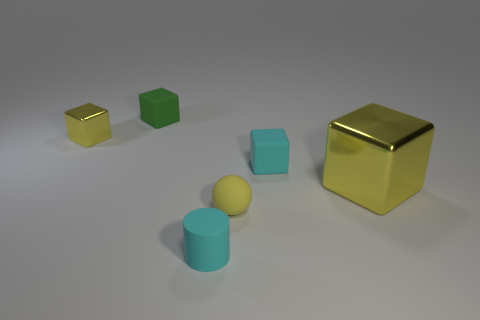How many things are to the left of the cyan matte object that is right of the cyan rubber cylinder?
Your response must be concise. 4. There is a cyan cylinder; are there any rubber cubes in front of it?
Your answer should be compact. No. There is a yellow object that is in front of the shiny block that is on the right side of the small yellow metallic thing; what is its shape?
Offer a very short reply. Sphere. Is the number of tiny objects that are behind the tiny matte ball less than the number of tiny yellow shiny blocks that are in front of the big yellow thing?
Your response must be concise. No. The small metal object that is the same shape as the big metallic thing is what color?
Offer a very short reply. Yellow. How many tiny rubber objects are in front of the small yellow cube and behind the yellow matte sphere?
Your response must be concise. 1. Is the number of tiny cyan rubber blocks that are behind the tiny green thing greater than the number of metallic blocks that are left of the tiny yellow shiny thing?
Ensure brevity in your answer.  No. The cyan cube is what size?
Give a very brief answer. Small. Is there a big yellow metal object that has the same shape as the tiny green object?
Ensure brevity in your answer.  Yes. There is a small green object; does it have the same shape as the small yellow object on the right side of the small cyan rubber cylinder?
Your answer should be very brief. No. 